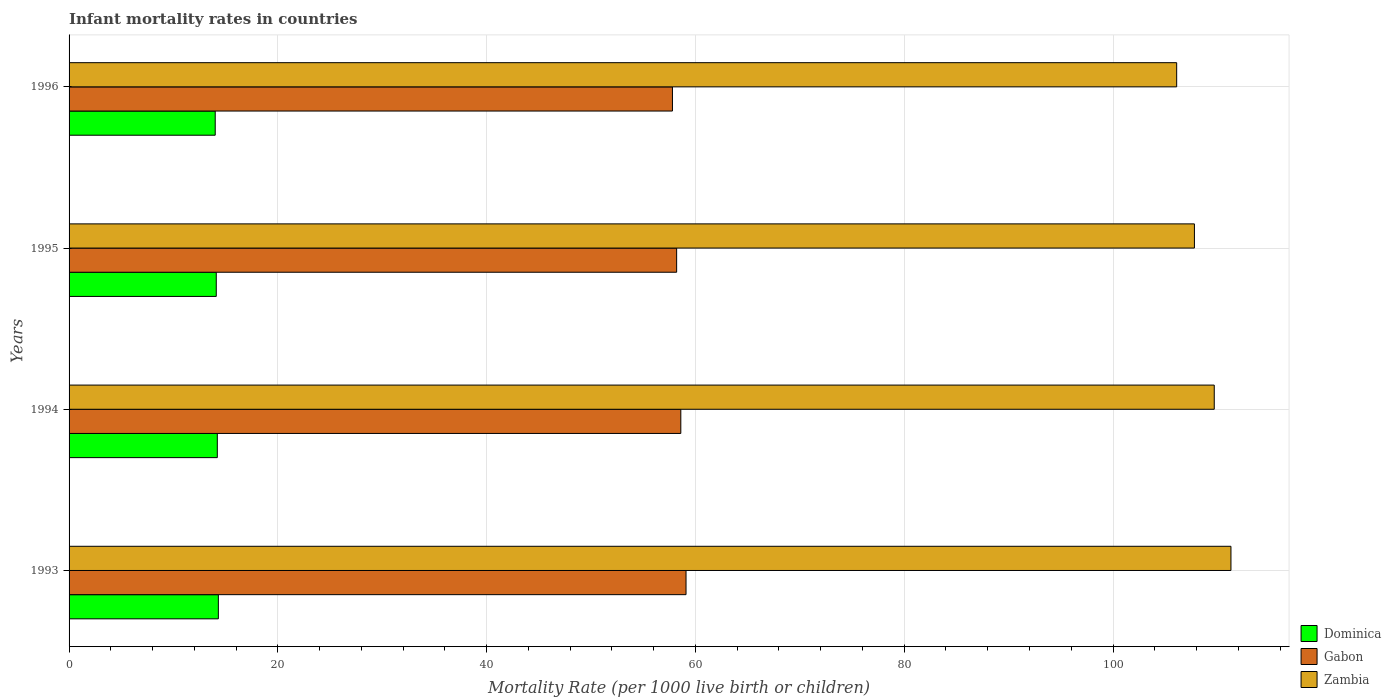How many groups of bars are there?
Your response must be concise. 4. Are the number of bars on each tick of the Y-axis equal?
Keep it short and to the point. Yes. What is the label of the 3rd group of bars from the top?
Give a very brief answer. 1994. What is the infant mortality rate in Zambia in 1995?
Provide a short and direct response. 107.8. Across all years, what is the maximum infant mortality rate in Zambia?
Your response must be concise. 111.3. Across all years, what is the minimum infant mortality rate in Zambia?
Your answer should be very brief. 106.1. In which year was the infant mortality rate in Zambia minimum?
Offer a very short reply. 1996. What is the total infant mortality rate in Gabon in the graph?
Ensure brevity in your answer.  233.7. What is the difference between the infant mortality rate in Dominica in 1995 and that in 1996?
Offer a very short reply. 0.1. What is the difference between the infant mortality rate in Zambia in 1993 and the infant mortality rate in Dominica in 1996?
Offer a terse response. 97.3. What is the average infant mortality rate in Gabon per year?
Your response must be concise. 58.42. In the year 1996, what is the difference between the infant mortality rate in Dominica and infant mortality rate in Gabon?
Your answer should be compact. -43.8. What is the ratio of the infant mortality rate in Dominica in 1995 to that in 1996?
Give a very brief answer. 1.01. Is the difference between the infant mortality rate in Dominica in 1994 and 1996 greater than the difference between the infant mortality rate in Gabon in 1994 and 1996?
Offer a very short reply. No. What is the difference between the highest and the second highest infant mortality rate in Zambia?
Keep it short and to the point. 1.6. What is the difference between the highest and the lowest infant mortality rate in Gabon?
Give a very brief answer. 1.3. In how many years, is the infant mortality rate in Dominica greater than the average infant mortality rate in Dominica taken over all years?
Make the answer very short. 2. Is the sum of the infant mortality rate in Zambia in 1993 and 1994 greater than the maximum infant mortality rate in Dominica across all years?
Keep it short and to the point. Yes. What does the 3rd bar from the top in 1994 represents?
Your answer should be compact. Dominica. What does the 2nd bar from the bottom in 1994 represents?
Your answer should be compact. Gabon. Is it the case that in every year, the sum of the infant mortality rate in Zambia and infant mortality rate in Gabon is greater than the infant mortality rate in Dominica?
Your answer should be compact. Yes. How many bars are there?
Offer a very short reply. 12. Are the values on the major ticks of X-axis written in scientific E-notation?
Your response must be concise. No. Where does the legend appear in the graph?
Ensure brevity in your answer.  Bottom right. How many legend labels are there?
Ensure brevity in your answer.  3. What is the title of the graph?
Offer a terse response. Infant mortality rates in countries. Does "France" appear as one of the legend labels in the graph?
Offer a terse response. No. What is the label or title of the X-axis?
Your answer should be very brief. Mortality Rate (per 1000 live birth or children). What is the Mortality Rate (per 1000 live birth or children) of Dominica in 1993?
Provide a succinct answer. 14.3. What is the Mortality Rate (per 1000 live birth or children) in Gabon in 1993?
Your response must be concise. 59.1. What is the Mortality Rate (per 1000 live birth or children) of Zambia in 1993?
Keep it short and to the point. 111.3. What is the Mortality Rate (per 1000 live birth or children) in Dominica in 1994?
Offer a terse response. 14.2. What is the Mortality Rate (per 1000 live birth or children) in Gabon in 1994?
Give a very brief answer. 58.6. What is the Mortality Rate (per 1000 live birth or children) in Zambia in 1994?
Your response must be concise. 109.7. What is the Mortality Rate (per 1000 live birth or children) of Dominica in 1995?
Your answer should be compact. 14.1. What is the Mortality Rate (per 1000 live birth or children) of Gabon in 1995?
Keep it short and to the point. 58.2. What is the Mortality Rate (per 1000 live birth or children) of Zambia in 1995?
Ensure brevity in your answer.  107.8. What is the Mortality Rate (per 1000 live birth or children) in Dominica in 1996?
Your answer should be compact. 14. What is the Mortality Rate (per 1000 live birth or children) of Gabon in 1996?
Offer a terse response. 57.8. What is the Mortality Rate (per 1000 live birth or children) in Zambia in 1996?
Your response must be concise. 106.1. Across all years, what is the maximum Mortality Rate (per 1000 live birth or children) of Dominica?
Provide a succinct answer. 14.3. Across all years, what is the maximum Mortality Rate (per 1000 live birth or children) of Gabon?
Provide a succinct answer. 59.1. Across all years, what is the maximum Mortality Rate (per 1000 live birth or children) in Zambia?
Make the answer very short. 111.3. Across all years, what is the minimum Mortality Rate (per 1000 live birth or children) of Gabon?
Offer a very short reply. 57.8. Across all years, what is the minimum Mortality Rate (per 1000 live birth or children) in Zambia?
Ensure brevity in your answer.  106.1. What is the total Mortality Rate (per 1000 live birth or children) of Dominica in the graph?
Ensure brevity in your answer.  56.6. What is the total Mortality Rate (per 1000 live birth or children) in Gabon in the graph?
Your answer should be very brief. 233.7. What is the total Mortality Rate (per 1000 live birth or children) in Zambia in the graph?
Your answer should be very brief. 434.9. What is the difference between the Mortality Rate (per 1000 live birth or children) of Gabon in 1993 and that in 1995?
Your answer should be very brief. 0.9. What is the difference between the Mortality Rate (per 1000 live birth or children) in Zambia in 1993 and that in 1995?
Your answer should be compact. 3.5. What is the difference between the Mortality Rate (per 1000 live birth or children) in Gabon in 1993 and that in 1996?
Provide a short and direct response. 1.3. What is the difference between the Mortality Rate (per 1000 live birth or children) in Gabon in 1994 and that in 1995?
Offer a terse response. 0.4. What is the difference between the Mortality Rate (per 1000 live birth or children) of Zambia in 1994 and that in 1995?
Your response must be concise. 1.9. What is the difference between the Mortality Rate (per 1000 live birth or children) in Dominica in 1995 and that in 1996?
Keep it short and to the point. 0.1. What is the difference between the Mortality Rate (per 1000 live birth or children) of Gabon in 1995 and that in 1996?
Your answer should be compact. 0.4. What is the difference between the Mortality Rate (per 1000 live birth or children) in Zambia in 1995 and that in 1996?
Give a very brief answer. 1.7. What is the difference between the Mortality Rate (per 1000 live birth or children) in Dominica in 1993 and the Mortality Rate (per 1000 live birth or children) in Gabon in 1994?
Your response must be concise. -44.3. What is the difference between the Mortality Rate (per 1000 live birth or children) in Dominica in 1993 and the Mortality Rate (per 1000 live birth or children) in Zambia in 1994?
Offer a very short reply. -95.4. What is the difference between the Mortality Rate (per 1000 live birth or children) in Gabon in 1993 and the Mortality Rate (per 1000 live birth or children) in Zambia in 1994?
Provide a succinct answer. -50.6. What is the difference between the Mortality Rate (per 1000 live birth or children) in Dominica in 1993 and the Mortality Rate (per 1000 live birth or children) in Gabon in 1995?
Your response must be concise. -43.9. What is the difference between the Mortality Rate (per 1000 live birth or children) in Dominica in 1993 and the Mortality Rate (per 1000 live birth or children) in Zambia in 1995?
Keep it short and to the point. -93.5. What is the difference between the Mortality Rate (per 1000 live birth or children) of Gabon in 1993 and the Mortality Rate (per 1000 live birth or children) of Zambia in 1995?
Offer a very short reply. -48.7. What is the difference between the Mortality Rate (per 1000 live birth or children) of Dominica in 1993 and the Mortality Rate (per 1000 live birth or children) of Gabon in 1996?
Offer a terse response. -43.5. What is the difference between the Mortality Rate (per 1000 live birth or children) of Dominica in 1993 and the Mortality Rate (per 1000 live birth or children) of Zambia in 1996?
Offer a terse response. -91.8. What is the difference between the Mortality Rate (per 1000 live birth or children) of Gabon in 1993 and the Mortality Rate (per 1000 live birth or children) of Zambia in 1996?
Your response must be concise. -47. What is the difference between the Mortality Rate (per 1000 live birth or children) in Dominica in 1994 and the Mortality Rate (per 1000 live birth or children) in Gabon in 1995?
Make the answer very short. -44. What is the difference between the Mortality Rate (per 1000 live birth or children) in Dominica in 1994 and the Mortality Rate (per 1000 live birth or children) in Zambia in 1995?
Offer a terse response. -93.6. What is the difference between the Mortality Rate (per 1000 live birth or children) in Gabon in 1994 and the Mortality Rate (per 1000 live birth or children) in Zambia in 1995?
Your response must be concise. -49.2. What is the difference between the Mortality Rate (per 1000 live birth or children) of Dominica in 1994 and the Mortality Rate (per 1000 live birth or children) of Gabon in 1996?
Offer a terse response. -43.6. What is the difference between the Mortality Rate (per 1000 live birth or children) of Dominica in 1994 and the Mortality Rate (per 1000 live birth or children) of Zambia in 1996?
Keep it short and to the point. -91.9. What is the difference between the Mortality Rate (per 1000 live birth or children) of Gabon in 1994 and the Mortality Rate (per 1000 live birth or children) of Zambia in 1996?
Keep it short and to the point. -47.5. What is the difference between the Mortality Rate (per 1000 live birth or children) of Dominica in 1995 and the Mortality Rate (per 1000 live birth or children) of Gabon in 1996?
Offer a very short reply. -43.7. What is the difference between the Mortality Rate (per 1000 live birth or children) of Dominica in 1995 and the Mortality Rate (per 1000 live birth or children) of Zambia in 1996?
Your answer should be very brief. -92. What is the difference between the Mortality Rate (per 1000 live birth or children) of Gabon in 1995 and the Mortality Rate (per 1000 live birth or children) of Zambia in 1996?
Give a very brief answer. -47.9. What is the average Mortality Rate (per 1000 live birth or children) in Dominica per year?
Your answer should be very brief. 14.15. What is the average Mortality Rate (per 1000 live birth or children) of Gabon per year?
Give a very brief answer. 58.42. What is the average Mortality Rate (per 1000 live birth or children) in Zambia per year?
Give a very brief answer. 108.72. In the year 1993, what is the difference between the Mortality Rate (per 1000 live birth or children) in Dominica and Mortality Rate (per 1000 live birth or children) in Gabon?
Your response must be concise. -44.8. In the year 1993, what is the difference between the Mortality Rate (per 1000 live birth or children) of Dominica and Mortality Rate (per 1000 live birth or children) of Zambia?
Your answer should be compact. -97. In the year 1993, what is the difference between the Mortality Rate (per 1000 live birth or children) of Gabon and Mortality Rate (per 1000 live birth or children) of Zambia?
Your answer should be very brief. -52.2. In the year 1994, what is the difference between the Mortality Rate (per 1000 live birth or children) of Dominica and Mortality Rate (per 1000 live birth or children) of Gabon?
Ensure brevity in your answer.  -44.4. In the year 1994, what is the difference between the Mortality Rate (per 1000 live birth or children) in Dominica and Mortality Rate (per 1000 live birth or children) in Zambia?
Provide a succinct answer. -95.5. In the year 1994, what is the difference between the Mortality Rate (per 1000 live birth or children) of Gabon and Mortality Rate (per 1000 live birth or children) of Zambia?
Your answer should be very brief. -51.1. In the year 1995, what is the difference between the Mortality Rate (per 1000 live birth or children) in Dominica and Mortality Rate (per 1000 live birth or children) in Gabon?
Offer a terse response. -44.1. In the year 1995, what is the difference between the Mortality Rate (per 1000 live birth or children) in Dominica and Mortality Rate (per 1000 live birth or children) in Zambia?
Your answer should be compact. -93.7. In the year 1995, what is the difference between the Mortality Rate (per 1000 live birth or children) in Gabon and Mortality Rate (per 1000 live birth or children) in Zambia?
Offer a very short reply. -49.6. In the year 1996, what is the difference between the Mortality Rate (per 1000 live birth or children) in Dominica and Mortality Rate (per 1000 live birth or children) in Gabon?
Your answer should be very brief. -43.8. In the year 1996, what is the difference between the Mortality Rate (per 1000 live birth or children) of Dominica and Mortality Rate (per 1000 live birth or children) of Zambia?
Provide a short and direct response. -92.1. In the year 1996, what is the difference between the Mortality Rate (per 1000 live birth or children) of Gabon and Mortality Rate (per 1000 live birth or children) of Zambia?
Provide a short and direct response. -48.3. What is the ratio of the Mortality Rate (per 1000 live birth or children) in Gabon in 1993 to that in 1994?
Offer a terse response. 1.01. What is the ratio of the Mortality Rate (per 1000 live birth or children) of Zambia in 1993 to that in 1994?
Provide a succinct answer. 1.01. What is the ratio of the Mortality Rate (per 1000 live birth or children) of Dominica in 1993 to that in 1995?
Give a very brief answer. 1.01. What is the ratio of the Mortality Rate (per 1000 live birth or children) in Gabon in 1993 to that in 1995?
Make the answer very short. 1.02. What is the ratio of the Mortality Rate (per 1000 live birth or children) in Zambia in 1993 to that in 1995?
Give a very brief answer. 1.03. What is the ratio of the Mortality Rate (per 1000 live birth or children) of Dominica in 1993 to that in 1996?
Offer a terse response. 1.02. What is the ratio of the Mortality Rate (per 1000 live birth or children) of Gabon in 1993 to that in 1996?
Provide a short and direct response. 1.02. What is the ratio of the Mortality Rate (per 1000 live birth or children) of Zambia in 1993 to that in 1996?
Make the answer very short. 1.05. What is the ratio of the Mortality Rate (per 1000 live birth or children) of Dominica in 1994 to that in 1995?
Give a very brief answer. 1.01. What is the ratio of the Mortality Rate (per 1000 live birth or children) of Gabon in 1994 to that in 1995?
Provide a succinct answer. 1.01. What is the ratio of the Mortality Rate (per 1000 live birth or children) of Zambia in 1994 to that in 1995?
Provide a short and direct response. 1.02. What is the ratio of the Mortality Rate (per 1000 live birth or children) in Dominica in 1994 to that in 1996?
Give a very brief answer. 1.01. What is the ratio of the Mortality Rate (per 1000 live birth or children) in Gabon in 1994 to that in 1996?
Provide a succinct answer. 1.01. What is the ratio of the Mortality Rate (per 1000 live birth or children) of Zambia in 1994 to that in 1996?
Ensure brevity in your answer.  1.03. What is the ratio of the Mortality Rate (per 1000 live birth or children) of Dominica in 1995 to that in 1996?
Ensure brevity in your answer.  1.01. What is the difference between the highest and the second highest Mortality Rate (per 1000 live birth or children) of Dominica?
Ensure brevity in your answer.  0.1. What is the difference between the highest and the second highest Mortality Rate (per 1000 live birth or children) of Gabon?
Offer a very short reply. 0.5. What is the difference between the highest and the lowest Mortality Rate (per 1000 live birth or children) in Dominica?
Make the answer very short. 0.3. What is the difference between the highest and the lowest Mortality Rate (per 1000 live birth or children) in Gabon?
Your answer should be very brief. 1.3. What is the difference between the highest and the lowest Mortality Rate (per 1000 live birth or children) of Zambia?
Your answer should be very brief. 5.2. 